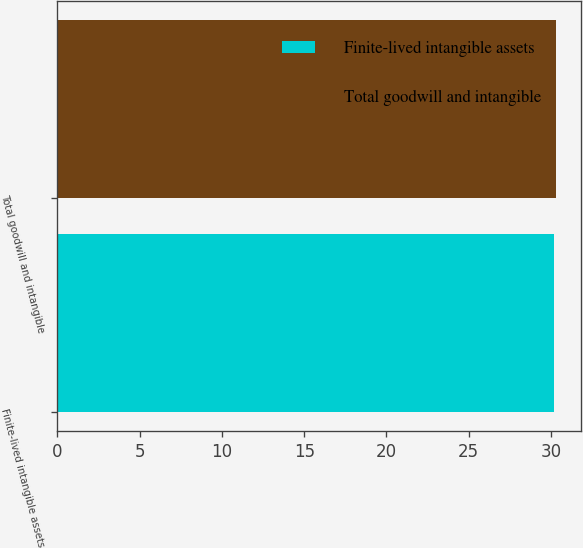<chart> <loc_0><loc_0><loc_500><loc_500><bar_chart><fcel>Finite-lived intangible assets<fcel>Total goodwill and intangible<nl><fcel>30.2<fcel>30.3<nl></chart> 